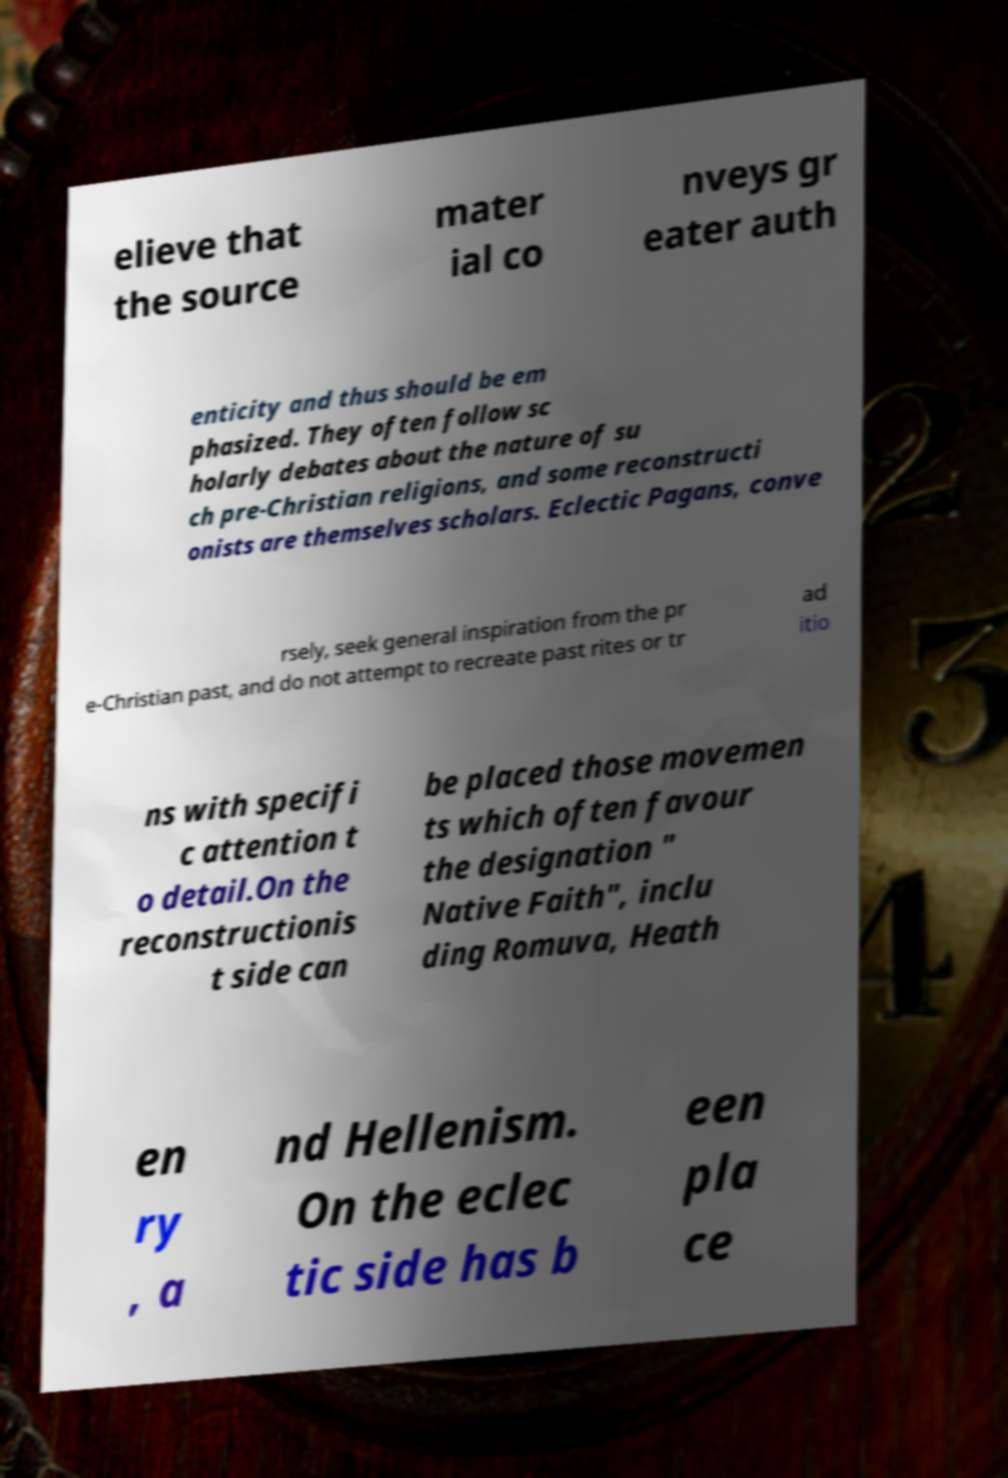Can you read and provide the text displayed in the image?This photo seems to have some interesting text. Can you extract and type it out for me? elieve that the source mater ial co nveys gr eater auth enticity and thus should be em phasized. They often follow sc holarly debates about the nature of su ch pre-Christian religions, and some reconstructi onists are themselves scholars. Eclectic Pagans, conve rsely, seek general inspiration from the pr e-Christian past, and do not attempt to recreate past rites or tr ad itio ns with specifi c attention t o detail.On the reconstructionis t side can be placed those movemen ts which often favour the designation " Native Faith", inclu ding Romuva, Heath en ry , a nd Hellenism. On the eclec tic side has b een pla ce 